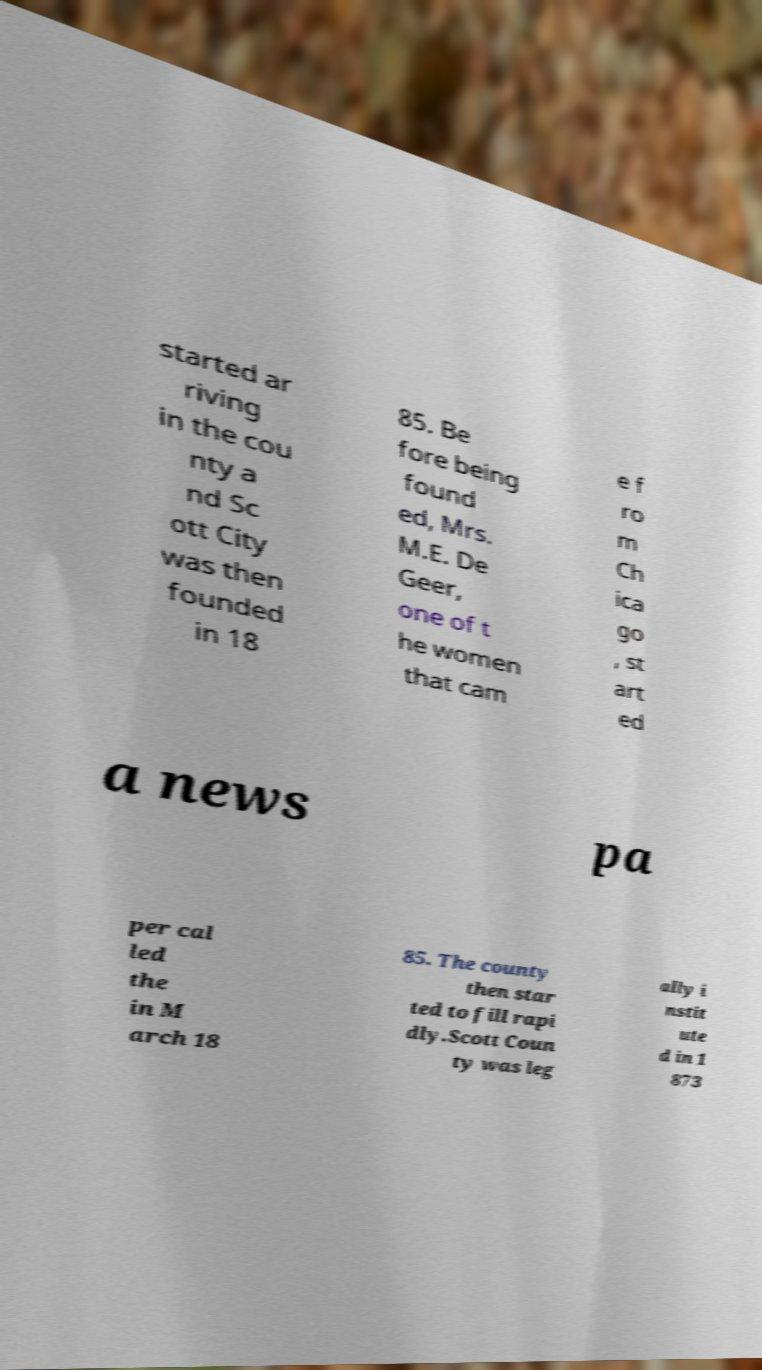Could you extract and type out the text from this image? started ar riving in the cou nty a nd Sc ott City was then founded in 18 85. Be fore being found ed, Mrs. M.E. De Geer, one of t he women that cam e f ro m Ch ica go , st art ed a news pa per cal led the in M arch 18 85. The county then star ted to fill rapi dly.Scott Coun ty was leg ally i nstit ute d in 1 873 